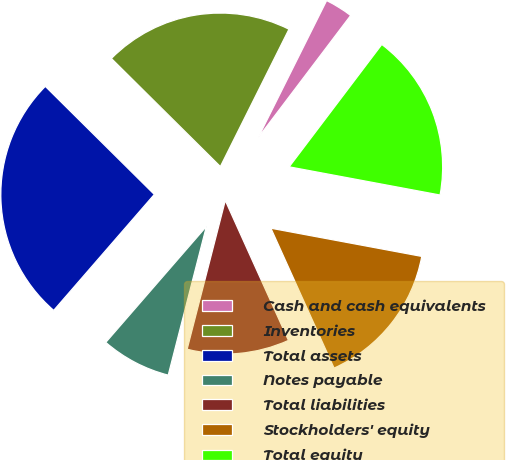Convert chart. <chart><loc_0><loc_0><loc_500><loc_500><pie_chart><fcel>Cash and cash equivalents<fcel>Inventories<fcel>Total assets<fcel>Notes payable<fcel>Total liabilities<fcel>Stockholders' equity<fcel>Total equity<nl><fcel>2.94%<fcel>19.94%<fcel>26.06%<fcel>7.38%<fcel>10.75%<fcel>15.31%<fcel>17.63%<nl></chart> 